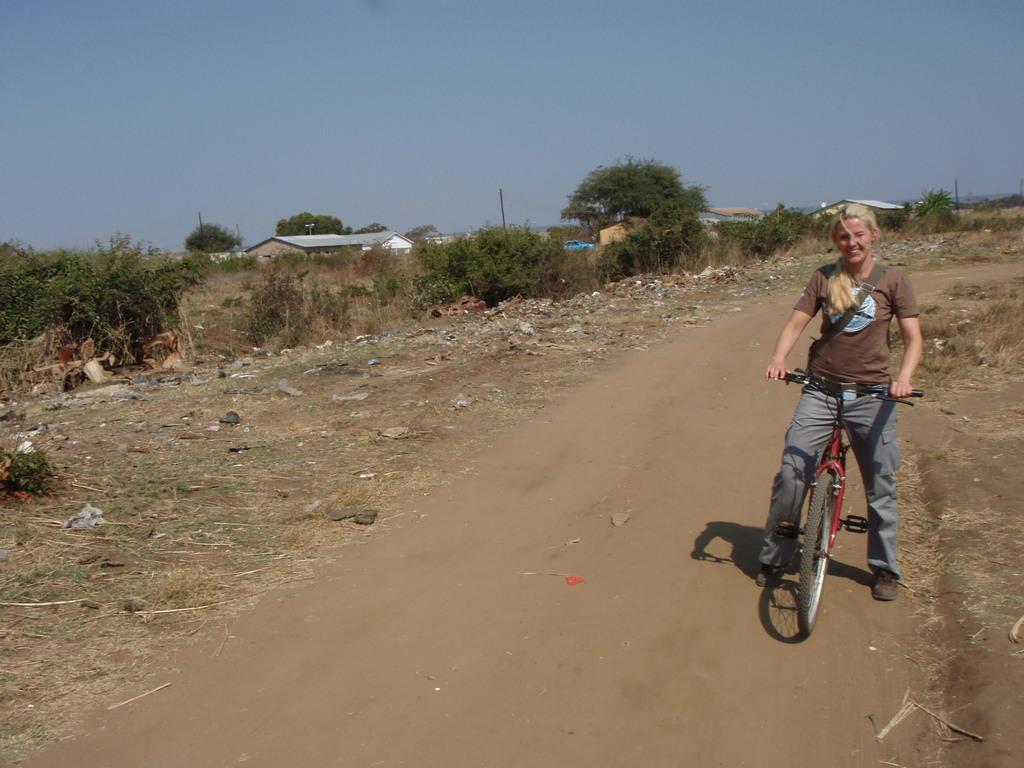Describe this image in one or two sentences. In the image there is a woman with blond hair on bicycle on the path, on either side of her there is a grassland and on the right side there is a building in the background with trees all around it and above its sky. 